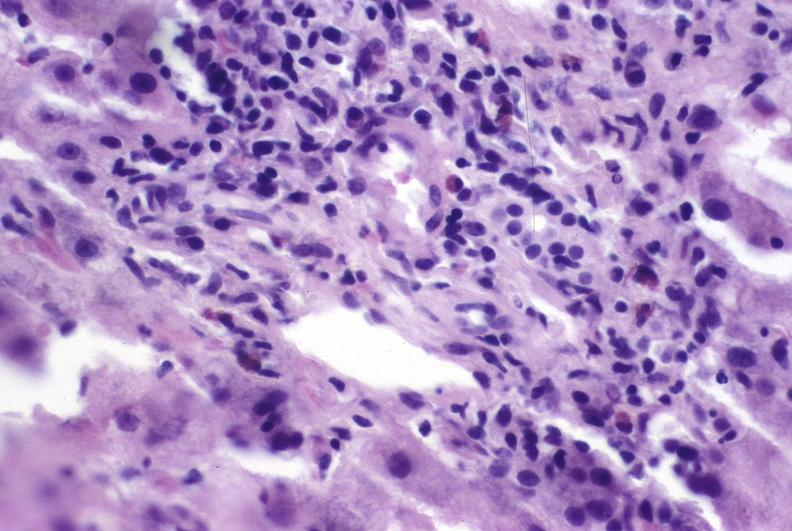s choanal atresia present?
Answer the question using a single word or phrase. No 